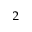<formula> <loc_0><loc_0><loc_500><loc_500>_ { 2 }</formula> 